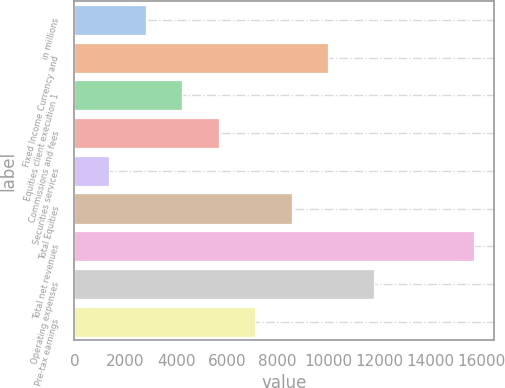<chart> <loc_0><loc_0><loc_500><loc_500><bar_chart><fcel>in millions<fcel>Fixed Income Currency and<fcel>Equities client execution 1<fcel>Commissions and fees<fcel>Securities services<fcel>Total Equities<fcel>Total net revenues<fcel>Operating expenses<fcel>Pre-tax earnings<nl><fcel>2807.8<fcel>9981.8<fcel>4242.6<fcel>5677.4<fcel>1373<fcel>8547<fcel>15721<fcel>11792<fcel>7112.2<nl></chart> 